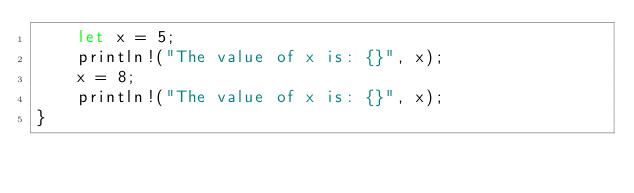Convert code to text. <code><loc_0><loc_0><loc_500><loc_500><_Rust_>    let x = 5;
    println!("The value of x is: {}", x);
    x = 8;
    println!("The value of x is: {}", x);
}
</code> 